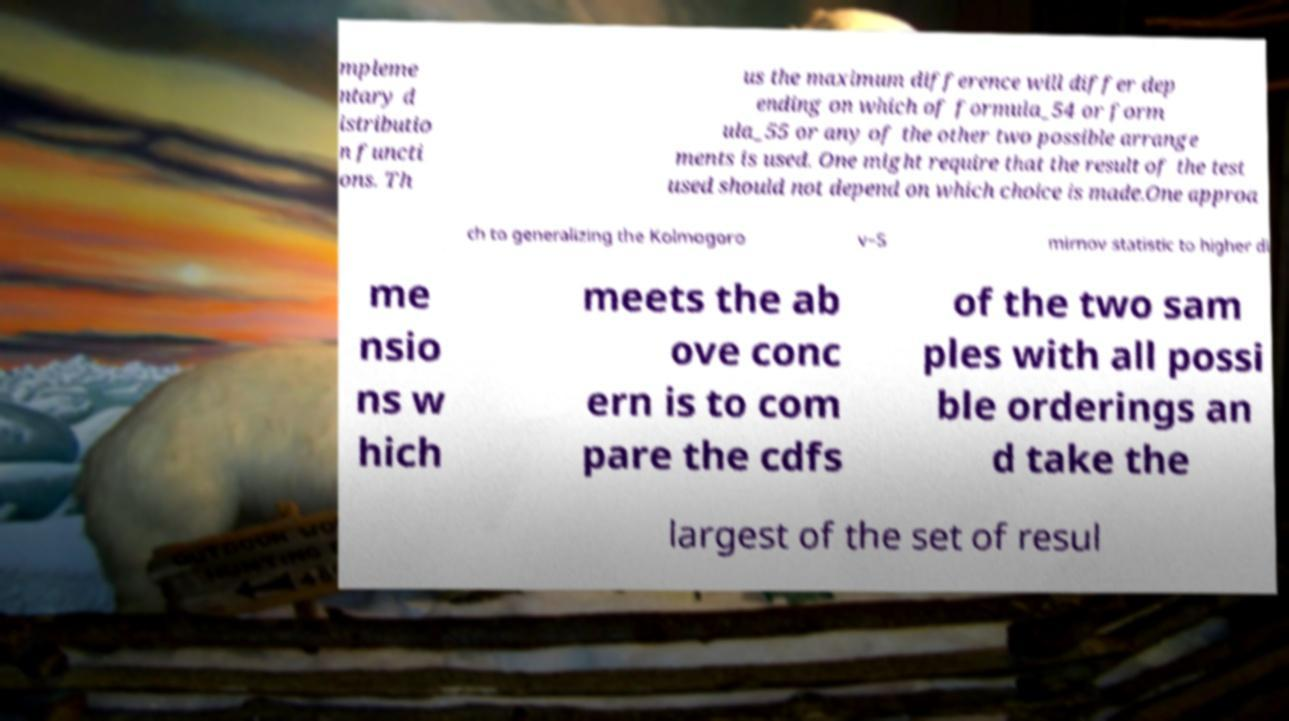Could you extract and type out the text from this image? mpleme ntary d istributio n functi ons. Th us the maximum difference will differ dep ending on which of formula_54 or form ula_55 or any of the other two possible arrange ments is used. One might require that the result of the test used should not depend on which choice is made.One approa ch to generalizing the Kolmogoro v–S mirnov statistic to higher di me nsio ns w hich meets the ab ove conc ern is to com pare the cdfs of the two sam ples with all possi ble orderings an d take the largest of the set of resul 